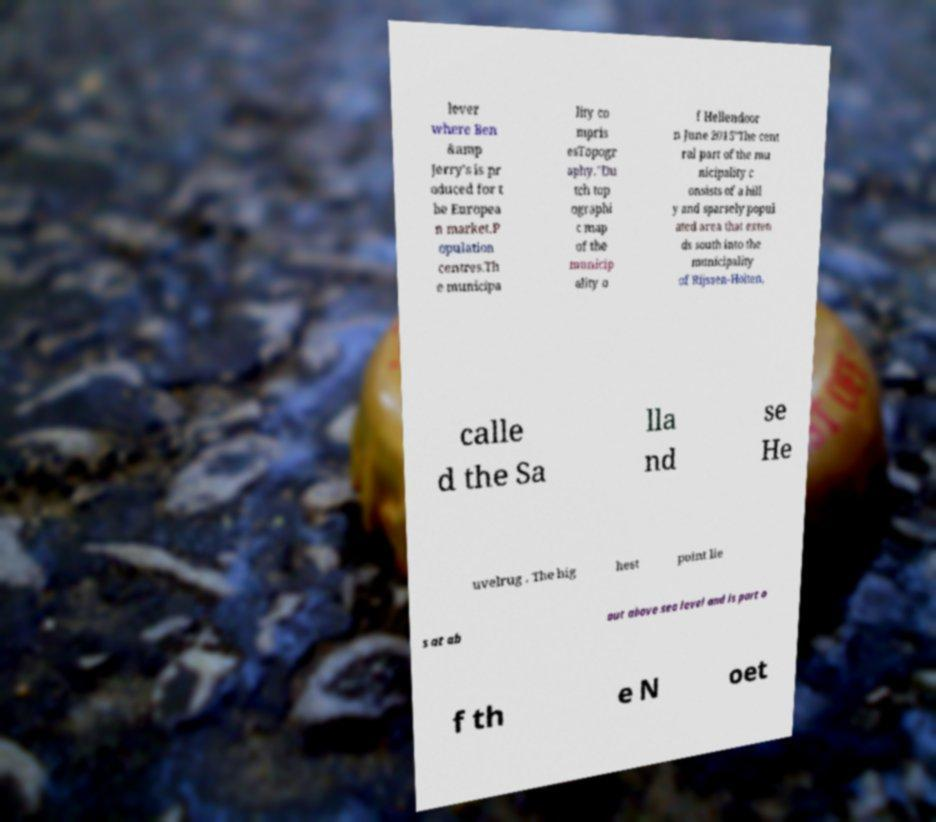What messages or text are displayed in this image? I need them in a readable, typed format. lever where Ben &amp Jerry's is pr oduced for t he Europea n market.P opulation centres.Th e municipa lity co mpris esTopogr aphy."Du tch top ographi c map of the municip ality o f Hellendoor n June 2015"The cent ral part of the mu nicipality c onsists of a hill y and sparsely popul ated area that exten ds south into the municipality of Rijssen-Holten, calle d the Sa lla nd se He uvelrug . The hig hest point lie s at ab out above sea level and is part o f th e N oet 